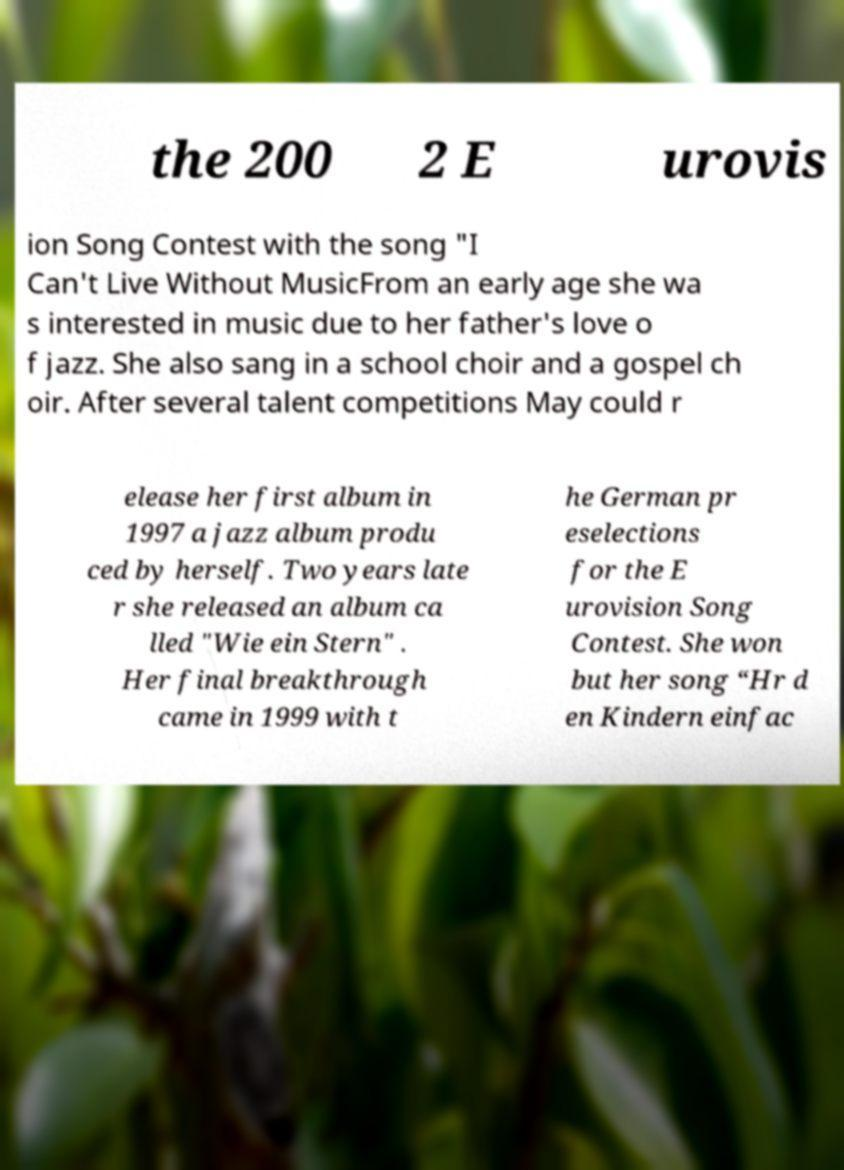Could you extract and type out the text from this image? the 200 2 E urovis ion Song Contest with the song "I Can't Live Without MusicFrom an early age she wa s interested in music due to her father's love o f jazz. She also sang in a school choir and a gospel ch oir. After several talent competitions May could r elease her first album in 1997 a jazz album produ ced by herself. Two years late r she released an album ca lled "Wie ein Stern" . Her final breakthrough came in 1999 with t he German pr eselections for the E urovision Song Contest. She won but her song “Hr d en Kindern einfac 